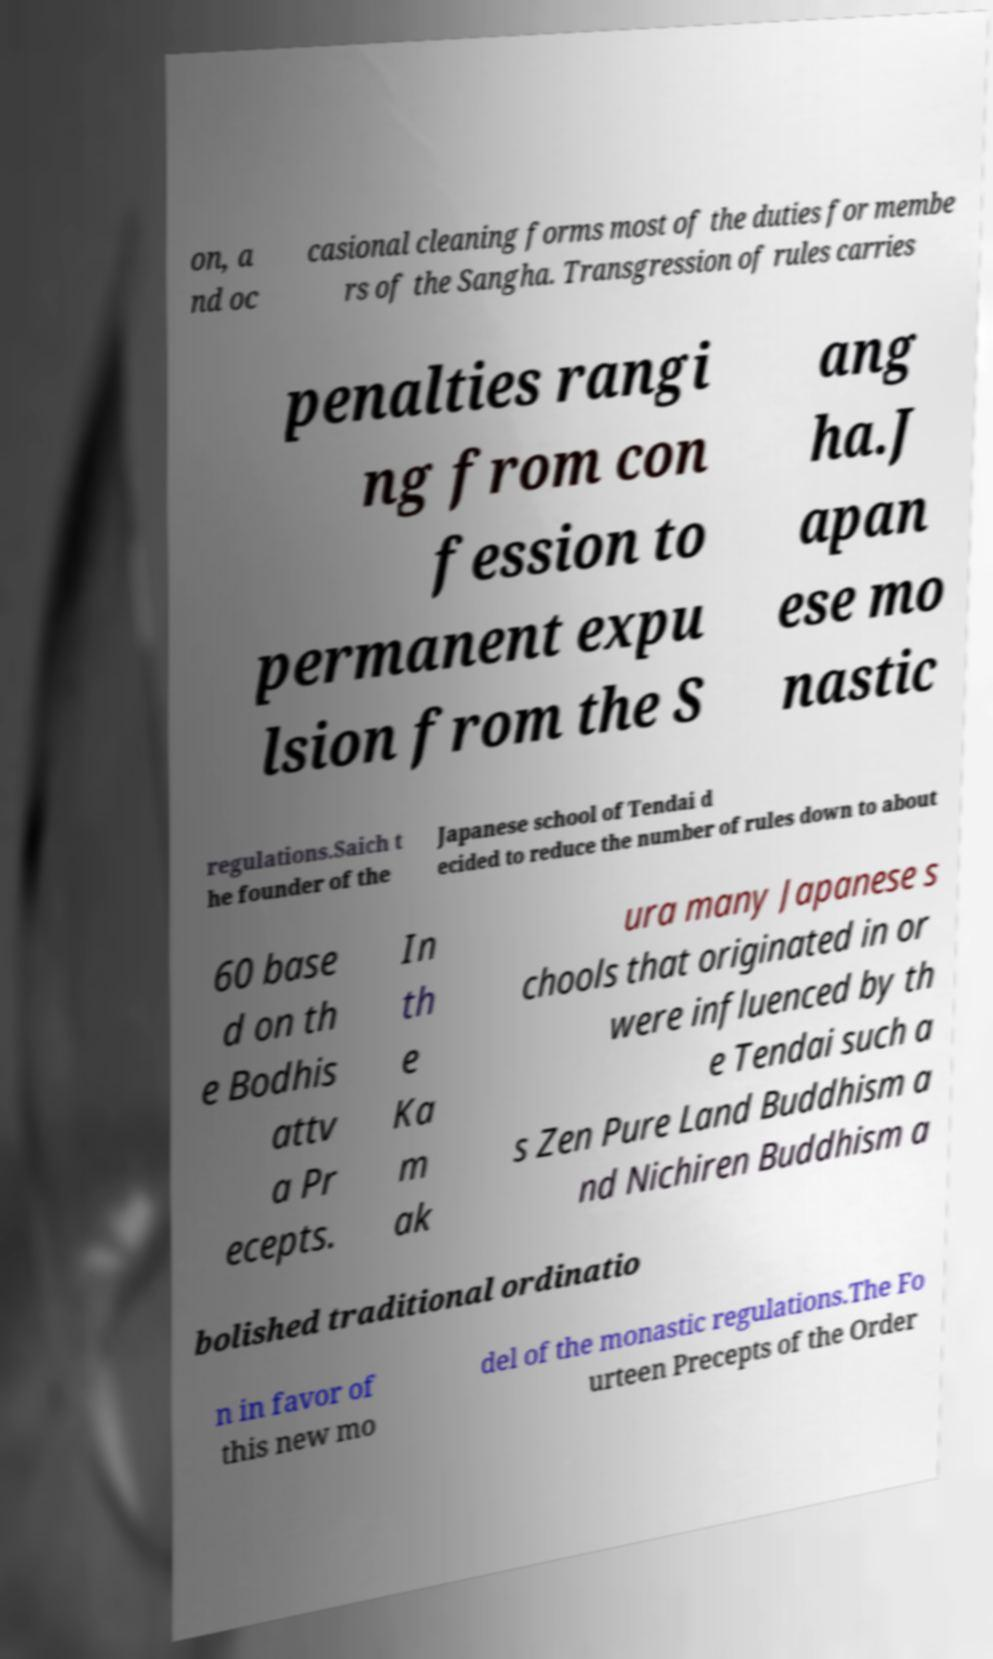Can you accurately transcribe the text from the provided image for me? on, a nd oc casional cleaning forms most of the duties for membe rs of the Sangha. Transgression of rules carries penalties rangi ng from con fession to permanent expu lsion from the S ang ha.J apan ese mo nastic regulations.Saich t he founder of the Japanese school of Tendai d ecided to reduce the number of rules down to about 60 base d on th e Bodhis attv a Pr ecepts. In th e Ka m ak ura many Japanese s chools that originated in or were influenced by th e Tendai such a s Zen Pure Land Buddhism a nd Nichiren Buddhism a bolished traditional ordinatio n in favor of this new mo del of the monastic regulations.The Fo urteen Precepts of the Order 